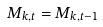Convert formula to latex. <formula><loc_0><loc_0><loc_500><loc_500>M _ { k , t } = M _ { k , t - 1 }</formula> 